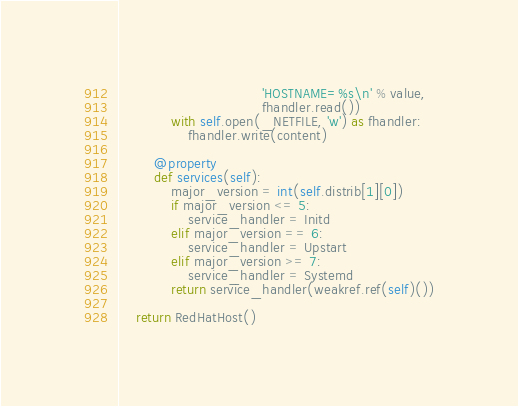Convert code to text. <code><loc_0><loc_0><loc_500><loc_500><_Python_>                                 'HOSTNAME=%s\n' % value,
                                 fhandler.read())
            with self.open(_NETFILE, 'w') as fhandler:
                fhandler.write(content)

        @property
        def services(self):
            major_version = int(self.distrib[1][0])
            if major_version <= 5:
                service_handler = Initd
            elif major_version == 6:
                service_handler = Upstart
            elif major_version >= 7:
                service_handler = Systemd
            return service_handler(weakref.ref(self)())

    return RedHatHost()
</code> 